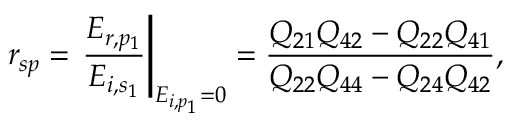<formula> <loc_0><loc_0><loc_500><loc_500>r _ { s p } = \frac { E _ { r , p _ { 1 } } } { E _ { i , s _ { 1 } } } \right | _ { E _ { i , p _ { 1 } } = 0 } = \frac { Q _ { 2 1 } Q _ { 4 2 } - Q _ { 2 2 } Q _ { 4 1 } } { Q _ { 2 2 } Q _ { 4 4 } - Q _ { 2 4 } Q _ { 4 2 } } ,</formula> 